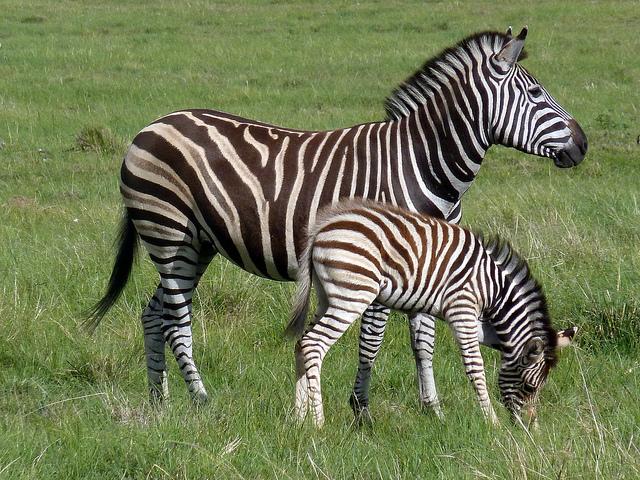What is the bigger zebra doing?
Keep it brief. Standing. Is the field lush?
Keep it brief. Yes. Is the zebra eating grass?
Write a very short answer. Yes. What is the relation of the Zebras?
Short answer required. Mother and child. What is the farthest zebra doing?
Answer briefly. Standing. What is the baby doing?
Keep it brief. Eating. Can the Zebras roam freely?
Answer briefly. Yes. How many ears can you see?
Write a very short answer. 4. Are both zebras adults?
Quick response, please. No. How old is animal?
Concise answer only. 1. 